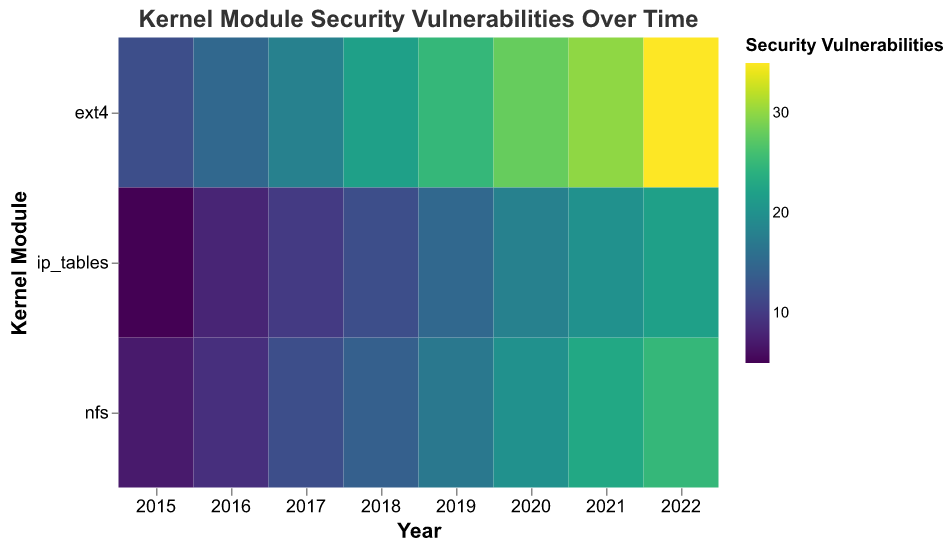What is the kernel module with the highest number of security vulnerabilities in 2022? The figure shows a heatmap where the color intensity represents the number of security vulnerabilities. In 2022, the color for the 'ext4' module is the most intense, indicating it has the highest number of vulnerabilities.
Answer: ext4 Which year had the lowest number of security vulnerabilities reported for the 'nfs' module? By looking at the heatmap, the lightest color for 'nfs' is in 2015, which indicates the lowest number of security vulnerabilities compared to other years.
Answer: 2015 For the 'ip_tables' module, how many security vulnerabilities were reported in 2018? The color intensity in the row corresponding to 'ip_tables' and the column for 2018 indicates the number of security vulnerabilities directly. From the color legend, the value can be read.
Answer: 12 What is the trend in the number of security vulnerabilities for the 'ext4' module from 2015 to 2022? The heatmap shows increasing color intensity for 'ext4' from 2015 to 2022, meaning the number of security vulnerabilities has been increasing each year.
Answer: Increasing Comparatively, which year saw the highest increase in security vulnerabilities for the 'nfs' module compared to the previous year? By comparing the color differences year-to-year for 'nfs', the largest change in color intensity occurs between 2019 and 2020, indicating the highest increase in vulnerabilities
Answer: 2020 On average, how many security vulnerabilities were reported for the 'ip_tables' module each year from 2015 to 2022? Sum the number of vulnerabilities for 'ip_tables' for each year (5 + 8 + 10 + 12 + 15 + 18 + 20 + 22) and divide by the number of years (8). (5 + 8 + 10 + 12 + 15 + 18 + 20 + 22) / 8 = 110 / 8 = 13.75
Answer: 13.75 Which kernel module consistently has more security vulnerabilities over the years? By looking at the rows and observing the overall color intensity, 'ext4' consistently has higher vulnerability levels when compared to 'nfs' and 'ip_tables'.
Answer: ext4 What can be inferred about the correlation between kernel module type and an increase in vulnerabilities over time? The heatmap suggests a positive correlation as all kernel modules (ext4, nfs, ip_tables) show a gradual increase in the number of security vulnerabilities over the years, indicated by the increasing color intensity from 2015 to 2022.
Answer: Positive correlation Between 2015 and 2020, how does the increase in reported vulnerabilities for 'ext4' compare to 'nfs'? Calculate the difference in vulnerabilities from 2015 to 2020 for both modules: 'ext4' from 12 to 28 (increase by 16), 'nfs' from 7 to 20 (increase by 13). Ext4 had a higher increase.
Answer: ext4 had a higher increase 